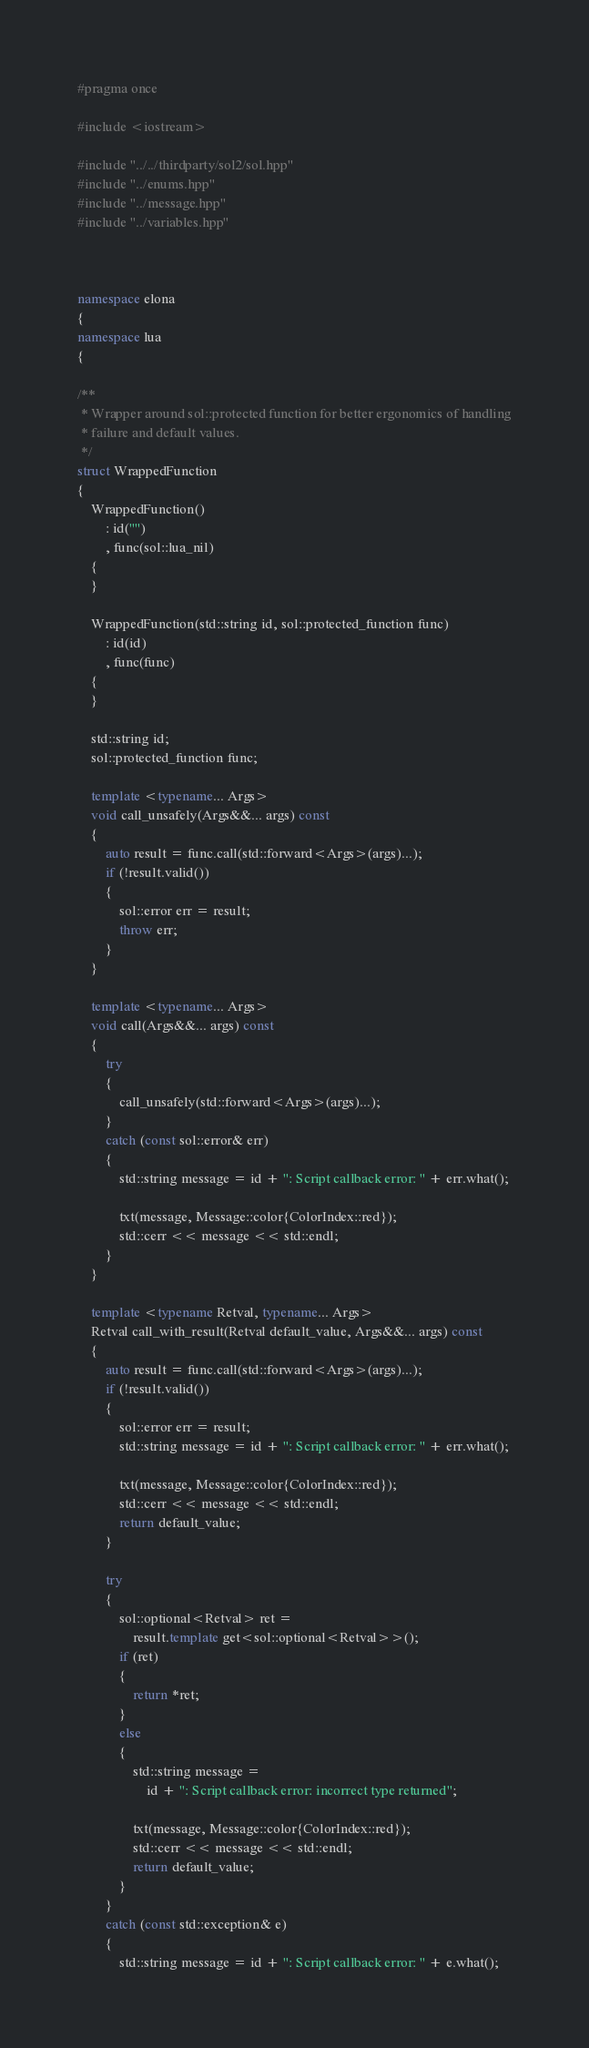Convert code to text. <code><loc_0><loc_0><loc_500><loc_500><_C++_>#pragma once

#include <iostream>

#include "../../thirdparty/sol2/sol.hpp"
#include "../enums.hpp"
#include "../message.hpp"
#include "../variables.hpp"



namespace elona
{
namespace lua
{

/**
 * Wrapper around sol::protected function for better ergonomics of handling
 * failure and default values.
 */
struct WrappedFunction
{
    WrappedFunction()
        : id("")
        , func(sol::lua_nil)
    {
    }

    WrappedFunction(std::string id, sol::protected_function func)
        : id(id)
        , func(func)
    {
    }

    std::string id;
    sol::protected_function func;

    template <typename... Args>
    void call_unsafely(Args&&... args) const
    {
        auto result = func.call(std::forward<Args>(args)...);
        if (!result.valid())
        {
            sol::error err = result;
            throw err;
        }
    }

    template <typename... Args>
    void call(Args&&... args) const
    {
        try
        {
            call_unsafely(std::forward<Args>(args)...);
        }
        catch (const sol::error& err)
        {
            std::string message = id + ": Script callback error: " + err.what();

            txt(message, Message::color{ColorIndex::red});
            std::cerr << message << std::endl;
        }
    }

    template <typename Retval, typename... Args>
    Retval call_with_result(Retval default_value, Args&&... args) const
    {
        auto result = func.call(std::forward<Args>(args)...);
        if (!result.valid())
        {
            sol::error err = result;
            std::string message = id + ": Script callback error: " + err.what();

            txt(message, Message::color{ColorIndex::red});
            std::cerr << message << std::endl;
            return default_value;
        }

        try
        {
            sol::optional<Retval> ret =
                result.template get<sol::optional<Retval>>();
            if (ret)
            {
                return *ret;
            }
            else
            {
                std::string message =
                    id + ": Script callback error: incorrect type returned";

                txt(message, Message::color{ColorIndex::red});
                std::cerr << message << std::endl;
                return default_value;
            }
        }
        catch (const std::exception& e)
        {
            std::string message = id + ": Script callback error: " + e.what();
</code> 